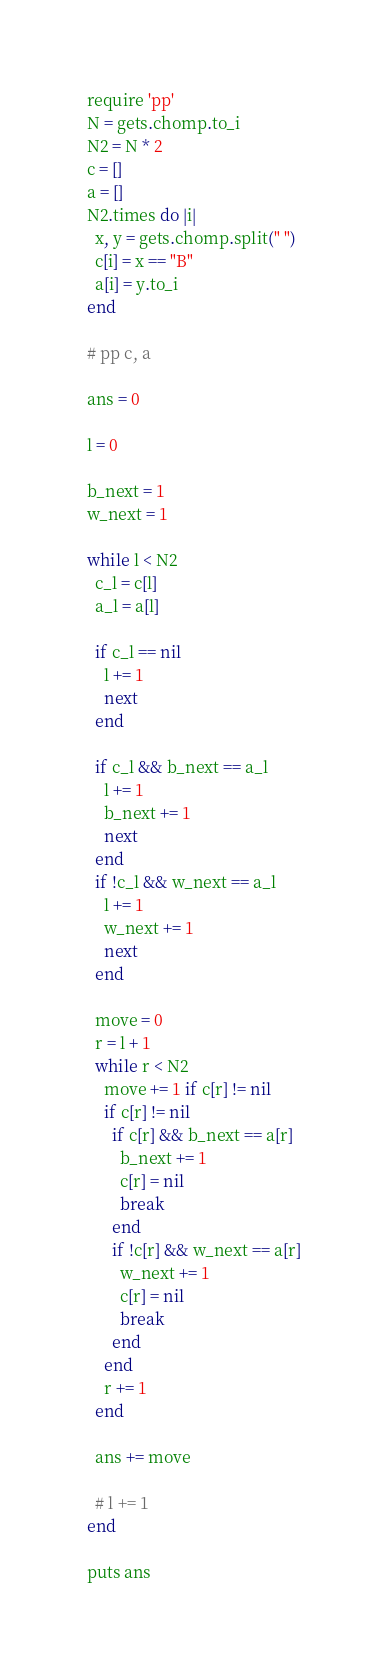Convert code to text. <code><loc_0><loc_0><loc_500><loc_500><_Ruby_>require 'pp'
N = gets.chomp.to_i
N2 = N * 2
c = []
a = []
N2.times do |i|
  x, y = gets.chomp.split(" ")
  c[i] = x == "B"
  a[i] = y.to_i
end

# pp c, a

ans = 0

l = 0

b_next = 1
w_next = 1

while l < N2
  c_l = c[l]
  a_l = a[l]

  if c_l == nil
    l += 1
    next
  end

  if c_l && b_next == a_l
    l += 1
    b_next += 1
    next
  end
  if !c_l && w_next == a_l
    l += 1
    w_next += 1
    next
  end

  move = 0
  r = l + 1
  while r < N2
    move += 1 if c[r] != nil
    if c[r] != nil
      if c[r] && b_next == a[r]
        b_next += 1
        c[r] = nil
        break
      end
      if !c[r] && w_next == a[r]
        w_next += 1
        c[r] = nil
        break
      end
    end
    r += 1
  end

  ans += move

  # l += 1
end

puts ans
</code> 